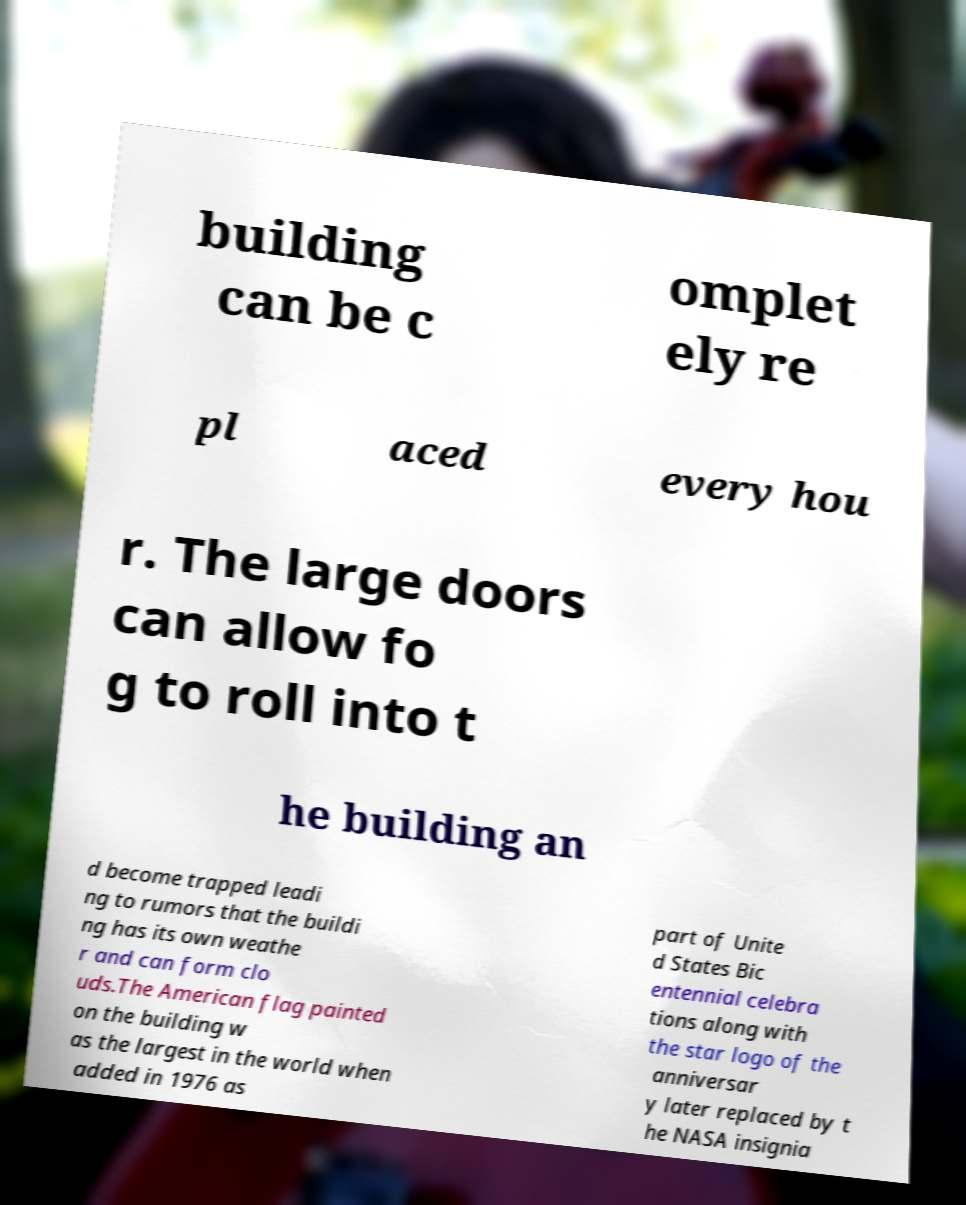I need the written content from this picture converted into text. Can you do that? building can be c omplet ely re pl aced every hou r. The large doors can allow fo g to roll into t he building an d become trapped leadi ng to rumors that the buildi ng has its own weathe r and can form clo uds.The American flag painted on the building w as the largest in the world when added in 1976 as part of Unite d States Bic entennial celebra tions along with the star logo of the anniversar y later replaced by t he NASA insignia 